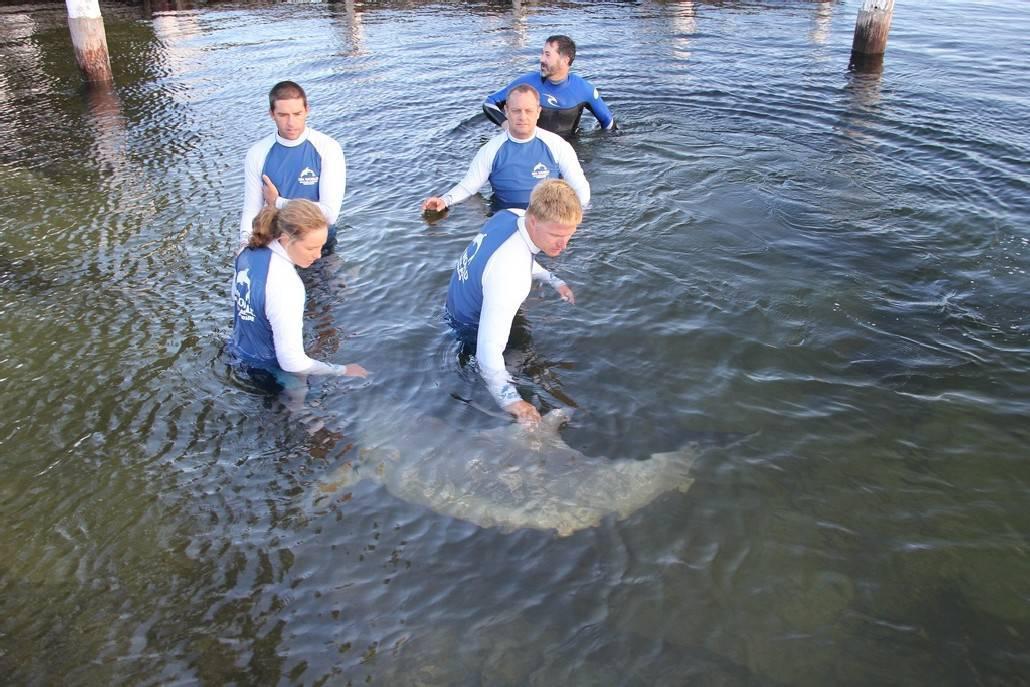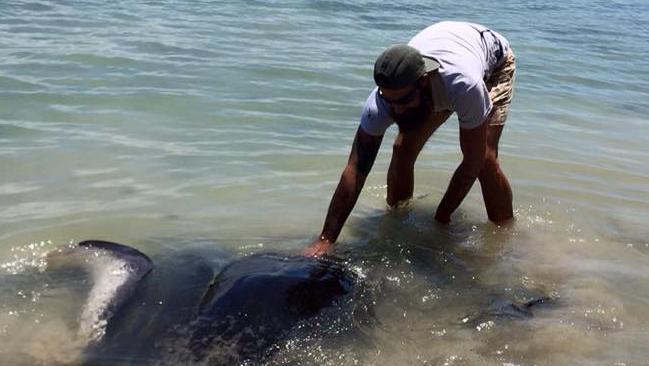The first image is the image on the left, the second image is the image on the right. For the images displayed, is the sentence "An image shows one man standing in water and bending toward a stingray." factually correct? Answer yes or no. Yes. The first image is the image on the left, the second image is the image on the right. For the images displayed, is the sentence "A man is interacting with a sea animal in the water." factually correct? Answer yes or no. Yes. 